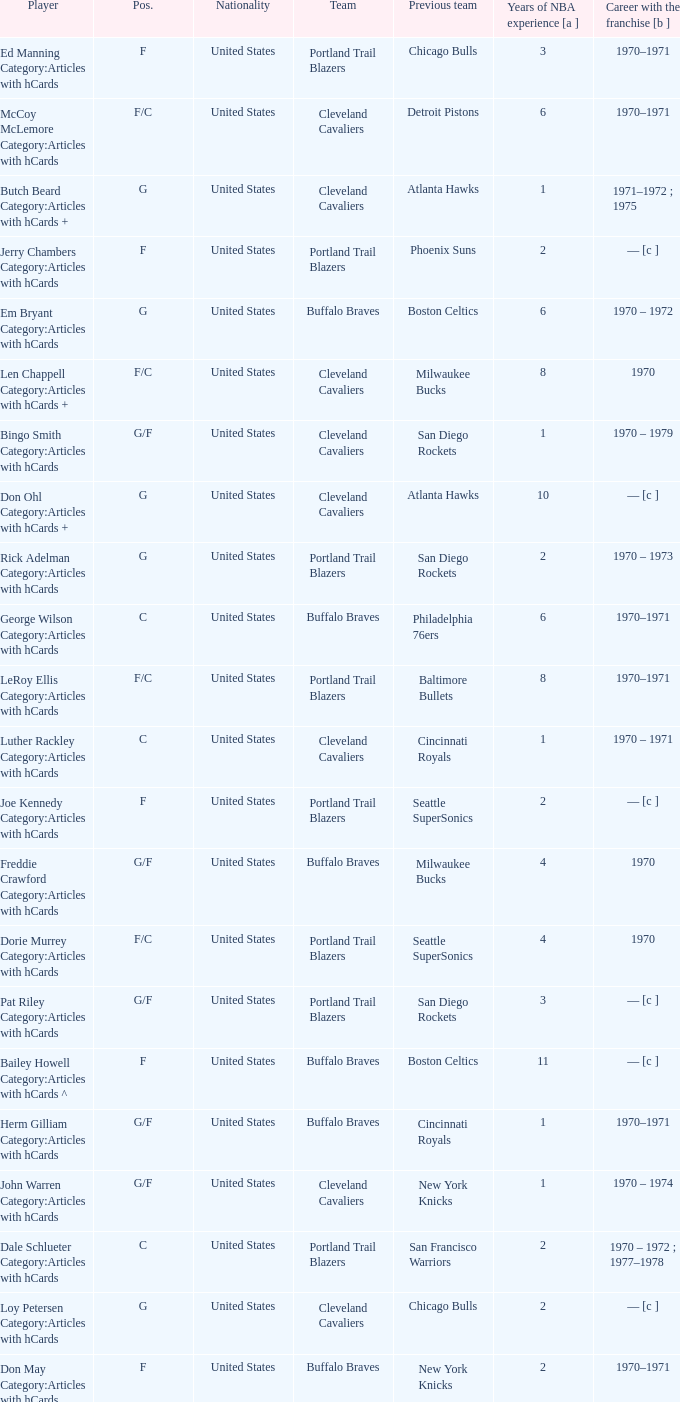Who is the player from the Buffalo Braves with the previous team Los Angeles Lakers and a career with the franchase in 1970? Mike Lynn Category:Articles with hCards. 